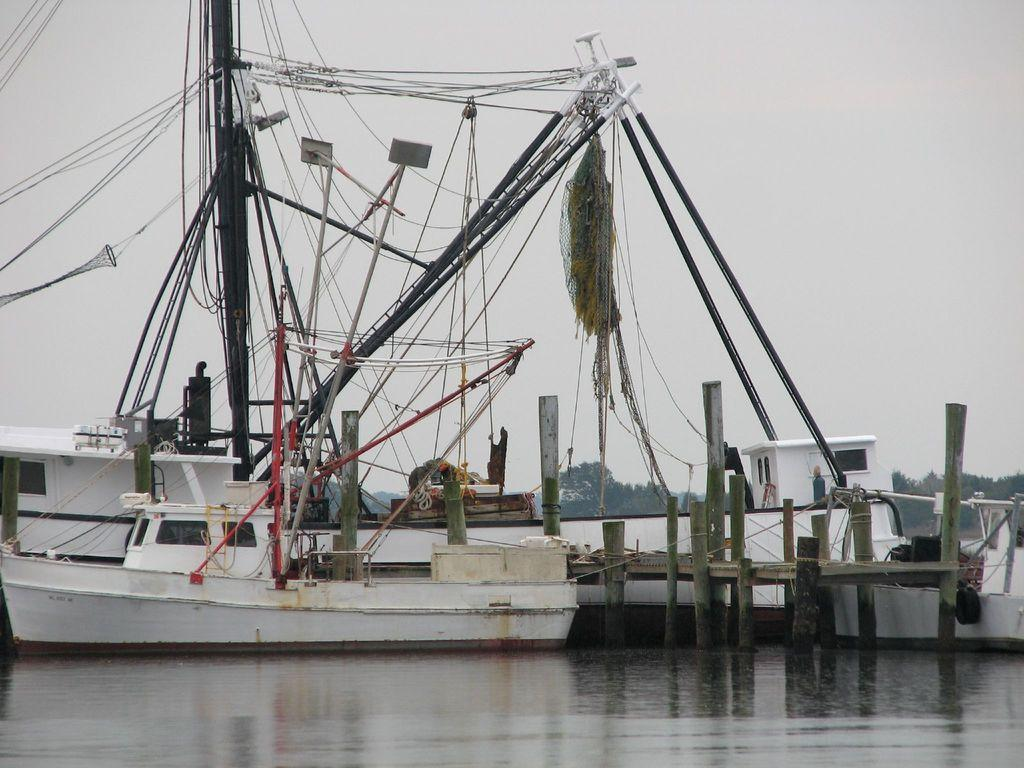What is floating on the water in the image? There are boats floating on the water in the image. What is the primary element in which the boats are situated? The boats are situated in water, which is visible in the image. What can be seen in the background of the image? There are trees and the sky visible in the background of the image. What type of apparatus is being used to sort the bricks in the image? There is no apparatus or bricks present in the image; it features boats floating on water with trees and the sky in the background. 